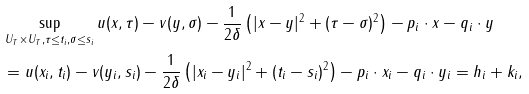Convert formula to latex. <formula><loc_0><loc_0><loc_500><loc_500>& \sup _ { U _ { T } \times U _ { T } , \tau \leq t _ { i } , \sigma \leq s _ { i } } u ( x , \tau ) - v ( y , \sigma ) - \frac { 1 } { 2 \delta } \left ( | x - y | ^ { 2 } + ( \tau - \sigma ) ^ { 2 } \right ) - p _ { i } \cdot x - q _ { i } \cdot y \\ & = u ( x _ { i } , t _ { i } ) - v ( y _ { i } , s _ { i } ) - \frac { 1 } { 2 \delta } \left ( | x _ { i } - y _ { i } | ^ { 2 } + ( t _ { i } - s _ { i } ) ^ { 2 } \right ) - p _ { i } \cdot x _ { i } - q _ { i } \cdot y _ { i } = h _ { i } + k _ { i } ,</formula> 